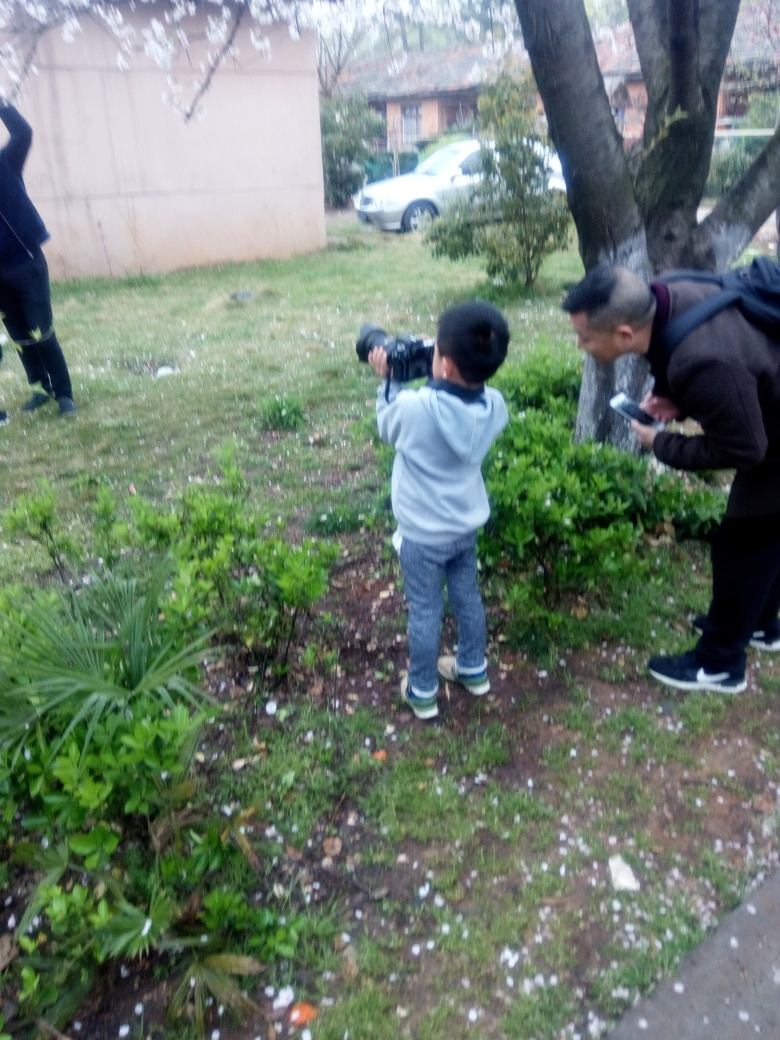What activity are the people in the image engaged in? The image depicts two individuals involved in a photography-related activity. The child appears to be taking a photograph with guidance from the adult. 